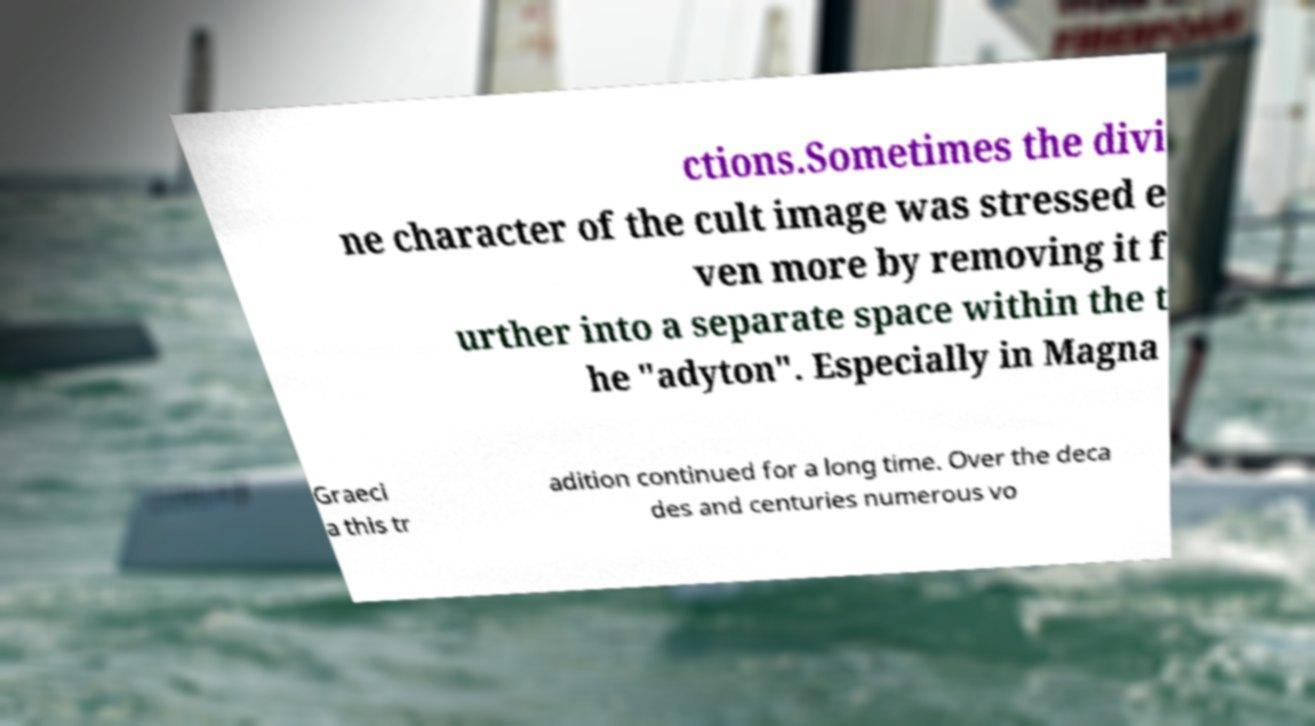Could you extract and type out the text from this image? ctions.Sometimes the divi ne character of the cult image was stressed e ven more by removing it f urther into a separate space within the t he "adyton". Especially in Magna Graeci a this tr adition continued for a long time. Over the deca des and centuries numerous vo 